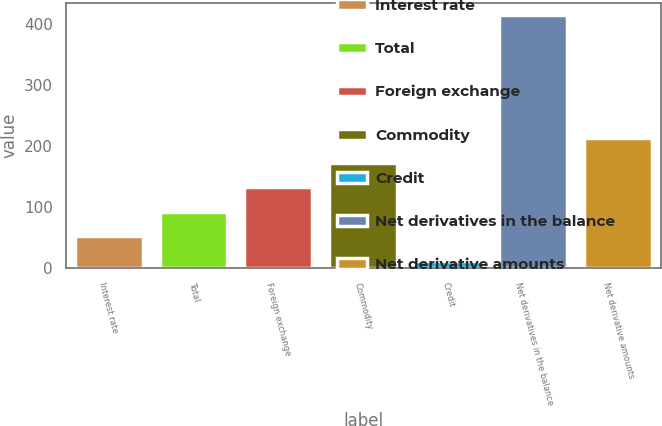<chart> <loc_0><loc_0><loc_500><loc_500><bar_chart><fcel>Interest rate<fcel>Total<fcel>Foreign exchange<fcel>Commodity<fcel>Credit<fcel>Net derivatives in the balance<fcel>Net derivative amounts<nl><fcel>52.2<fcel>92.4<fcel>132.6<fcel>172.8<fcel>12<fcel>414<fcel>213<nl></chart> 